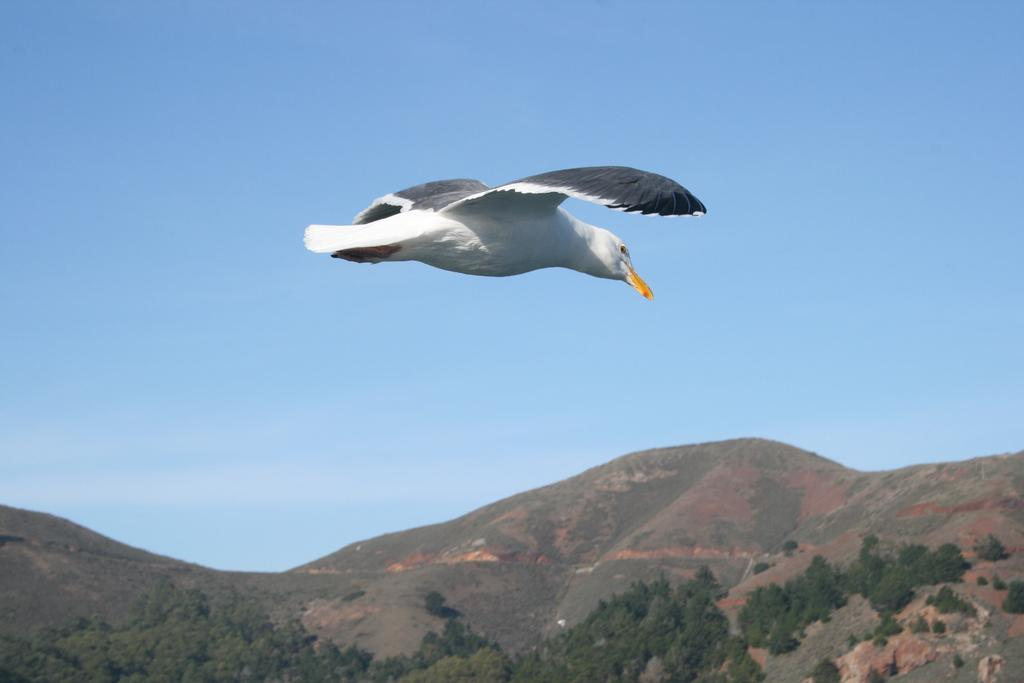What is the main subject in the center of the image? There is a bird in the center of the image. What can be seen at the bottom of the image? There are trees and hills at the bottom of the image. What is the condition of the sky in the image? The sky is clear in the image. What is the weather like in the image? It is sunny in the image. What type of transport can be seen learning to drive in the image? There is no transport or learning activity present in the image; it features a bird, trees, hills, and a clear sky. 